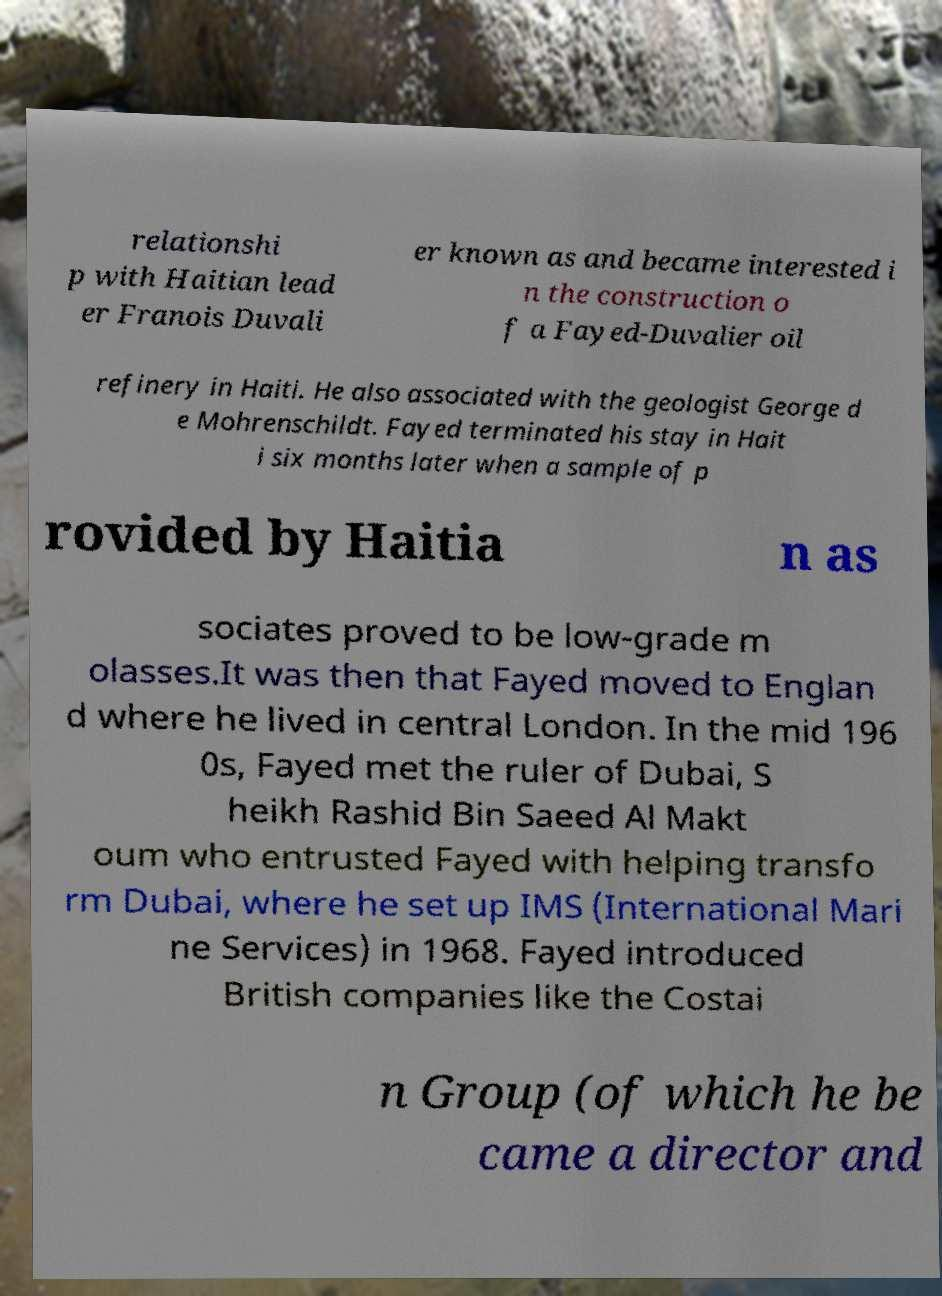There's text embedded in this image that I need extracted. Can you transcribe it verbatim? relationshi p with Haitian lead er Franois Duvali er known as and became interested i n the construction o f a Fayed-Duvalier oil refinery in Haiti. He also associated with the geologist George d e Mohrenschildt. Fayed terminated his stay in Hait i six months later when a sample of p rovided by Haitia n as sociates proved to be low-grade m olasses.It was then that Fayed moved to Englan d where he lived in central London. In the mid 196 0s, Fayed met the ruler of Dubai, S heikh Rashid Bin Saeed Al Makt oum who entrusted Fayed with helping transfo rm Dubai, where he set up IMS (International Mari ne Services) in 1968. Fayed introduced British companies like the Costai n Group (of which he be came a director and 